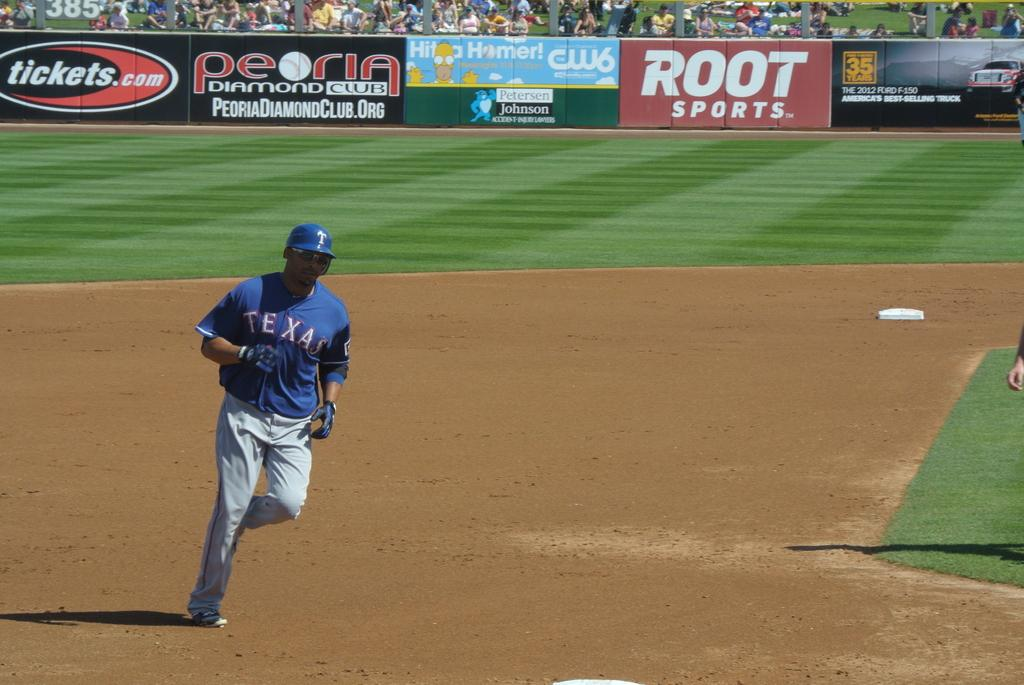Provide a one-sentence caption for the provided image. A baseball player with a Root sports banner in the background. 